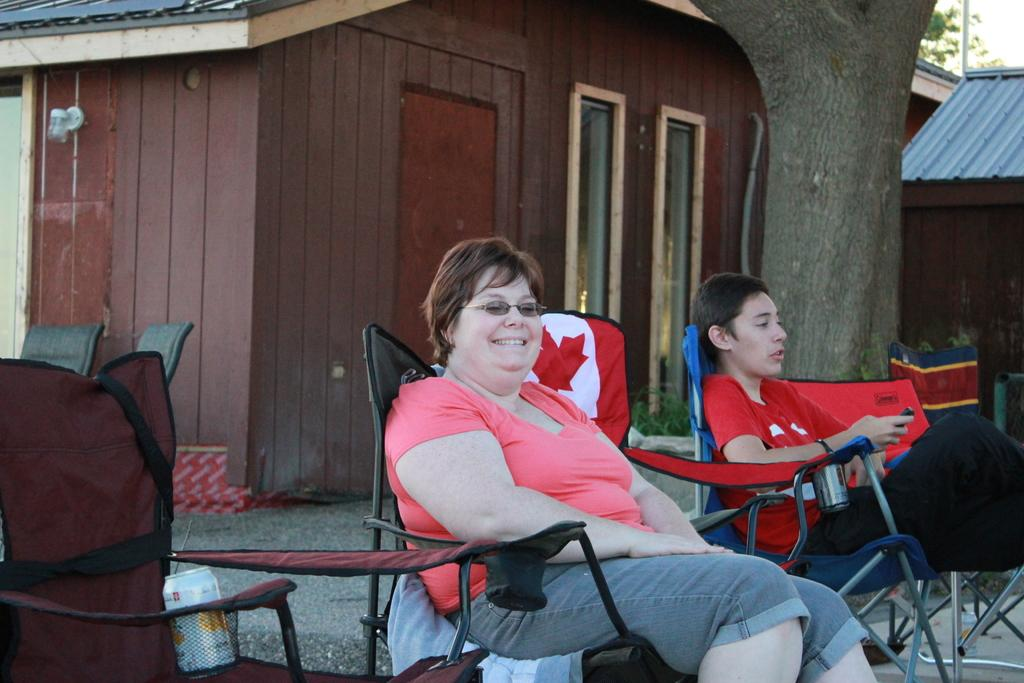What type of house is in the image? There is a wooden house in the image. What type of furniture is in the image? There are chairs in the image. How many people are sitting in the image? There are two people sitting in the image. What type of representative can be seen in the image? There is no representative present in the image; it features a wooden house, chairs, and two people sitting. What type of bird is perched on the truck in the image? There is no truck or bird present in the image. 